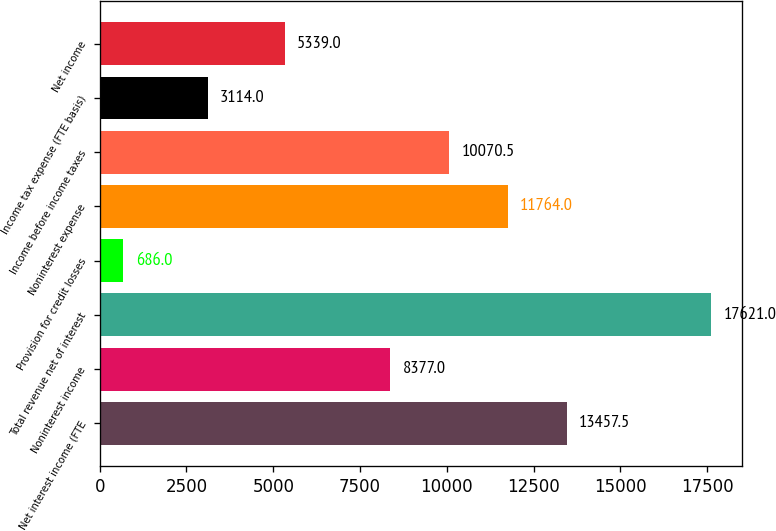Convert chart. <chart><loc_0><loc_0><loc_500><loc_500><bar_chart><fcel>Net interest income (FTE<fcel>Noninterest income<fcel>Total revenue net of interest<fcel>Provision for credit losses<fcel>Noninterest expense<fcel>Income before income taxes<fcel>Income tax expense (FTE basis)<fcel>Net income<nl><fcel>13457.5<fcel>8377<fcel>17621<fcel>686<fcel>11764<fcel>10070.5<fcel>3114<fcel>5339<nl></chart> 